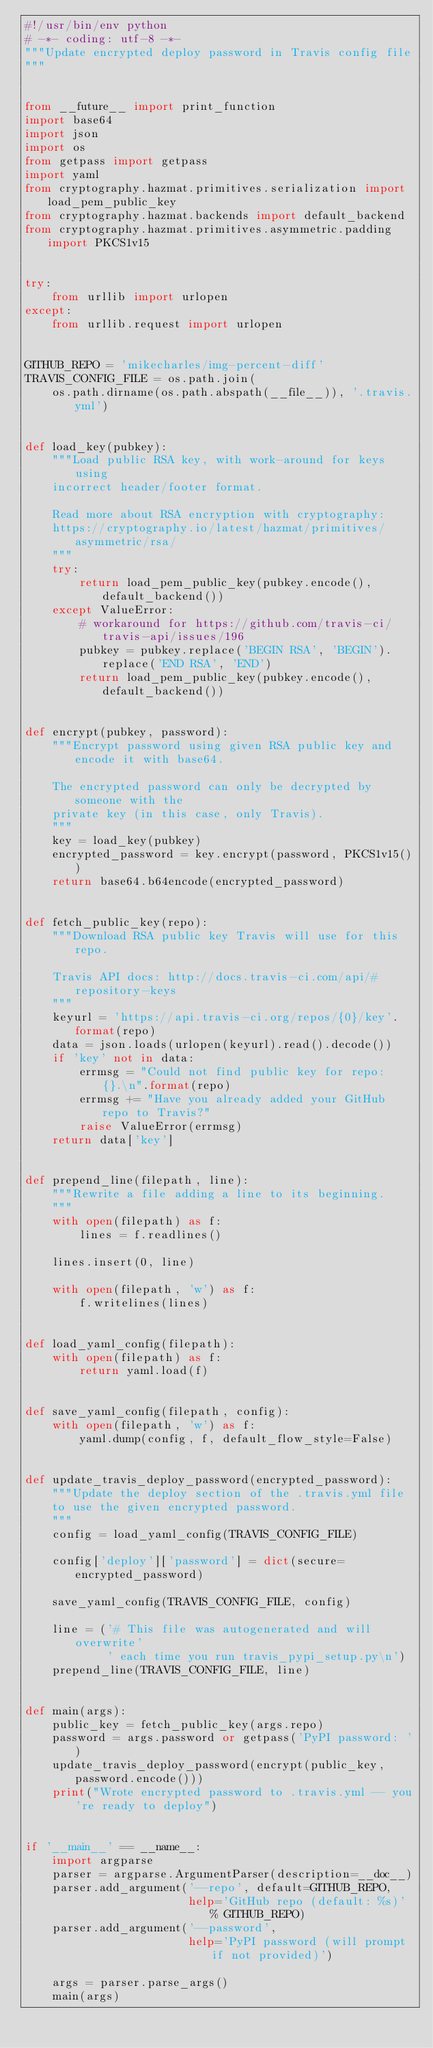Convert code to text. <code><loc_0><loc_0><loc_500><loc_500><_Python_>#!/usr/bin/env python
# -*- coding: utf-8 -*-
"""Update encrypted deploy password in Travis config file
"""


from __future__ import print_function
import base64
import json
import os
from getpass import getpass
import yaml
from cryptography.hazmat.primitives.serialization import load_pem_public_key
from cryptography.hazmat.backends import default_backend
from cryptography.hazmat.primitives.asymmetric.padding import PKCS1v15


try:
    from urllib import urlopen
except:
    from urllib.request import urlopen


GITHUB_REPO = 'mikecharles/img-percent-diff'
TRAVIS_CONFIG_FILE = os.path.join(
    os.path.dirname(os.path.abspath(__file__)), '.travis.yml')


def load_key(pubkey):
    """Load public RSA key, with work-around for keys using
    incorrect header/footer format.

    Read more about RSA encryption with cryptography:
    https://cryptography.io/latest/hazmat/primitives/asymmetric/rsa/
    """
    try:
        return load_pem_public_key(pubkey.encode(), default_backend())
    except ValueError:
        # workaround for https://github.com/travis-ci/travis-api/issues/196
        pubkey = pubkey.replace('BEGIN RSA', 'BEGIN').replace('END RSA', 'END')
        return load_pem_public_key(pubkey.encode(), default_backend())


def encrypt(pubkey, password):
    """Encrypt password using given RSA public key and encode it with base64.

    The encrypted password can only be decrypted by someone with the
    private key (in this case, only Travis).
    """
    key = load_key(pubkey)
    encrypted_password = key.encrypt(password, PKCS1v15())
    return base64.b64encode(encrypted_password)


def fetch_public_key(repo):
    """Download RSA public key Travis will use for this repo.

    Travis API docs: http://docs.travis-ci.com/api/#repository-keys
    """
    keyurl = 'https://api.travis-ci.org/repos/{0}/key'.format(repo)
    data = json.loads(urlopen(keyurl).read().decode())
    if 'key' not in data:
        errmsg = "Could not find public key for repo: {}.\n".format(repo)
        errmsg += "Have you already added your GitHub repo to Travis?"
        raise ValueError(errmsg)
    return data['key']


def prepend_line(filepath, line):
    """Rewrite a file adding a line to its beginning.
    """
    with open(filepath) as f:
        lines = f.readlines()

    lines.insert(0, line)

    with open(filepath, 'w') as f:
        f.writelines(lines)


def load_yaml_config(filepath):
    with open(filepath) as f:
        return yaml.load(f)


def save_yaml_config(filepath, config):
    with open(filepath, 'w') as f:
        yaml.dump(config, f, default_flow_style=False)


def update_travis_deploy_password(encrypted_password):
    """Update the deploy section of the .travis.yml file
    to use the given encrypted password.
    """
    config = load_yaml_config(TRAVIS_CONFIG_FILE)

    config['deploy']['password'] = dict(secure=encrypted_password)

    save_yaml_config(TRAVIS_CONFIG_FILE, config)

    line = ('# This file was autogenerated and will overwrite'
            ' each time you run travis_pypi_setup.py\n')
    prepend_line(TRAVIS_CONFIG_FILE, line)


def main(args):
    public_key = fetch_public_key(args.repo)
    password = args.password or getpass('PyPI password: ')
    update_travis_deploy_password(encrypt(public_key, password.encode()))
    print("Wrote encrypted password to .travis.yml -- you're ready to deploy")


if '__main__' == __name__:
    import argparse
    parser = argparse.ArgumentParser(description=__doc__)
    parser.add_argument('--repo', default=GITHUB_REPO,
                        help='GitHub repo (default: %s)' % GITHUB_REPO)
    parser.add_argument('--password',
                        help='PyPI password (will prompt if not provided)')

    args = parser.parse_args()
    main(args)
</code> 